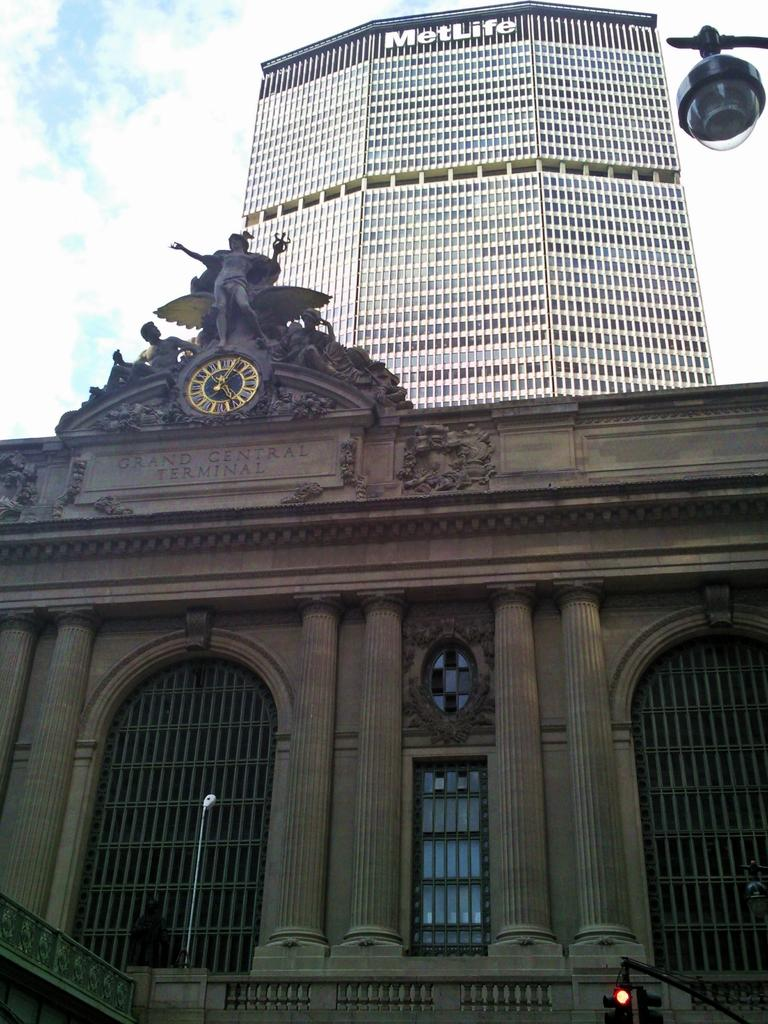<image>
Relay a brief, clear account of the picture shown. A brown building with a clock on the top in front of a tall MetLife building. 